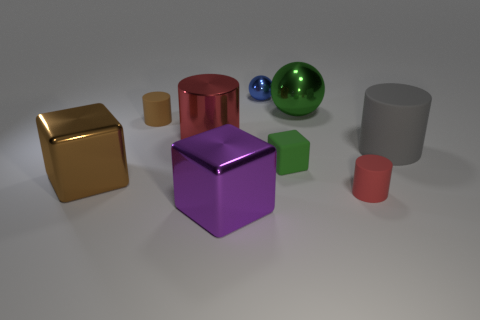What is the shape of the thing that is the same color as the tiny cube?
Your response must be concise. Sphere. What is the material of the cube that is in front of the tiny red thing?
Give a very brief answer. Metal. Is the size of the green block the same as the blue shiny thing?
Your response must be concise. Yes. Are there more red cylinders behind the gray matte object than big gray metal objects?
Offer a terse response. Yes. There is a block that is made of the same material as the brown cylinder; what size is it?
Offer a terse response. Small. Are there any tiny blue metal objects on the right side of the large red cylinder?
Ensure brevity in your answer.  Yes. Does the tiny red rubber thing have the same shape as the blue thing?
Make the answer very short. No. What is the size of the red object that is right of the big block that is to the right of the brown thing that is behind the brown metallic block?
Keep it short and to the point. Small. What is the tiny cube made of?
Offer a very short reply. Rubber. The rubber cube that is the same color as the large metallic ball is what size?
Provide a succinct answer. Small. 